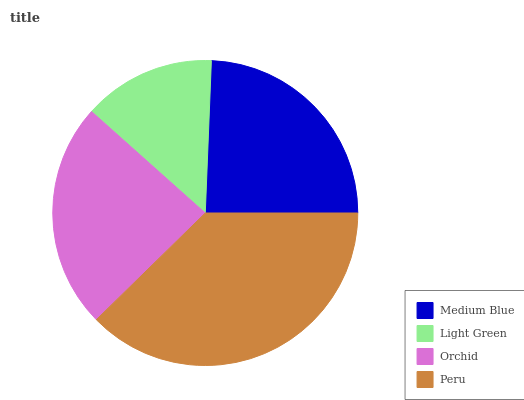Is Light Green the minimum?
Answer yes or no. Yes. Is Peru the maximum?
Answer yes or no. Yes. Is Orchid the minimum?
Answer yes or no. No. Is Orchid the maximum?
Answer yes or no. No. Is Orchid greater than Light Green?
Answer yes or no. Yes. Is Light Green less than Orchid?
Answer yes or no. Yes. Is Light Green greater than Orchid?
Answer yes or no. No. Is Orchid less than Light Green?
Answer yes or no. No. Is Medium Blue the high median?
Answer yes or no. Yes. Is Orchid the low median?
Answer yes or no. Yes. Is Orchid the high median?
Answer yes or no. No. Is Medium Blue the low median?
Answer yes or no. No. 